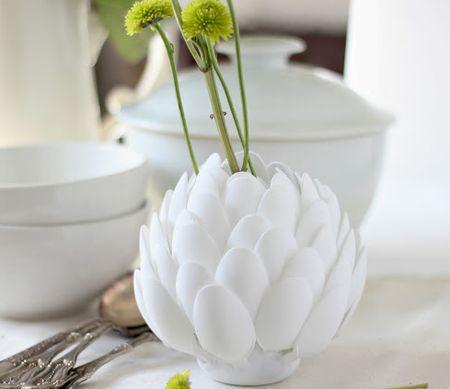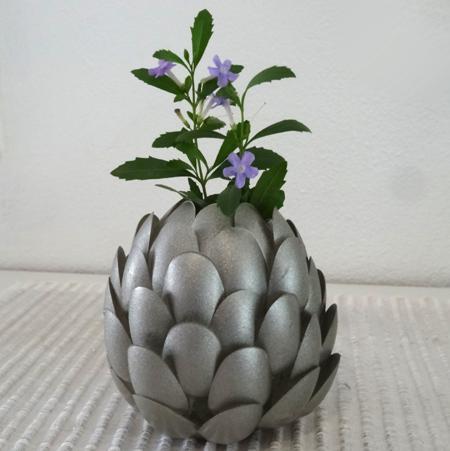The first image is the image on the left, the second image is the image on the right. Analyze the images presented: Is the assertion "Two artichoke shaped vases contain plants." valid? Answer yes or no. Yes. The first image is the image on the left, the second image is the image on the right. Considering the images on both sides, is "The left image contains an entirely green plant in an artichoke-shaped vase, and the right image contains a purple-flowered plant in an artichoke-shaped vase." valid? Answer yes or no. Yes. 